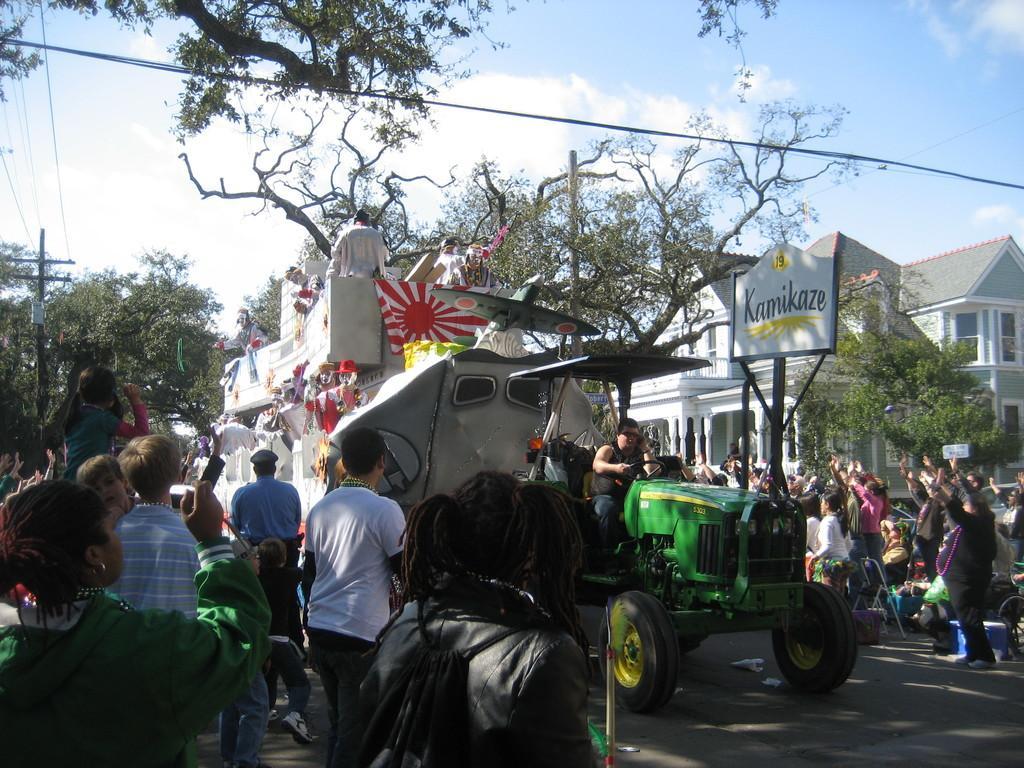Describe this image in one or two sentences. In the image there are many people standing. In between them on the road there is a vehicle with a man and at the back of the vehicle there is an object with toys and few people. In the background there are trees, pole with sign board and there is an electrical pole with wires. And also there are buildings with walls, windows and roofs. At the top of the image there is a sky. 